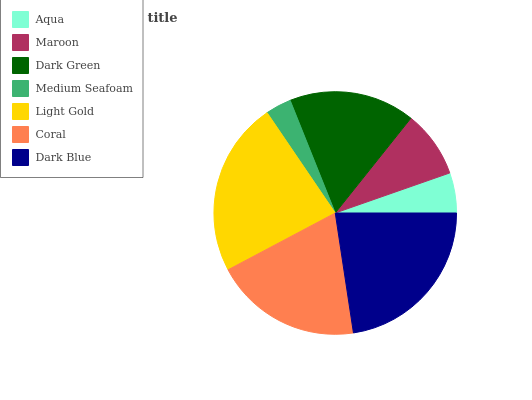Is Medium Seafoam the minimum?
Answer yes or no. Yes. Is Light Gold the maximum?
Answer yes or no. Yes. Is Maroon the minimum?
Answer yes or no. No. Is Maroon the maximum?
Answer yes or no. No. Is Maroon greater than Aqua?
Answer yes or no. Yes. Is Aqua less than Maroon?
Answer yes or no. Yes. Is Aqua greater than Maroon?
Answer yes or no. No. Is Maroon less than Aqua?
Answer yes or no. No. Is Dark Green the high median?
Answer yes or no. Yes. Is Dark Green the low median?
Answer yes or no. Yes. Is Dark Blue the high median?
Answer yes or no. No. Is Light Gold the low median?
Answer yes or no. No. 